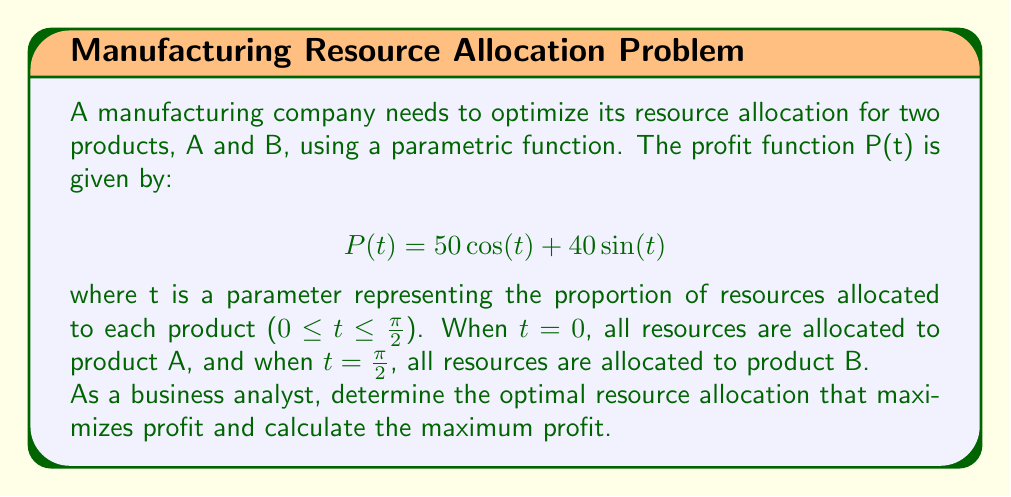Teach me how to tackle this problem. To solve this problem, we need to find the maximum value of the profit function P(t) within the given range of t.

1. First, let's find the derivative of P(t) with respect to t:
   $$P'(t) = -50\sin(t) + 40\cos(t)$$

2. To find the maximum, we set P'(t) = 0 and solve for t:
   $$-50\sin(t) + 40\cos(t) = 0$$
   $$40\cos(t) = 50\sin(t)$$
   $$\frac{\cos(t)}{\sin(t)} = \frac{5}{4}$$
   $$\tan(t) = \frac{4}{5}$$

3. Taking the inverse tangent of both sides:
   $$t = \arctan(\frac{4}{5}) \approx 0.6747 \text{ radians}$$

4. To confirm this is a maximum, we can check the second derivative:
   $$P''(t) = -50\cos(t) - 40\sin(t)$$
   At t ≈ 0.6747, P''(t) < 0, confirming it's a maximum.

5. The optimal resource allocation is:
   Product A: $\cos(0.6747) \approx 0.7808$ or 78.08%
   Product B: $\sin(0.6747) \approx 0.6247$ or 62.47%

6. Calculate the maximum profit by substituting t ≈ 0.6747 into the original function:
   $$P(0.6747) = 50\cos(0.6747) + 40\sin(0.6747) \approx 64.03$$

Therefore, the maximum profit is approximately $64.03 units.
Answer: The optimal resource allocation that maximizes profit is approximately 78.08% for product A and 62.47% for product B. The maximum profit achieved with this allocation is approximately $64.03 units. 